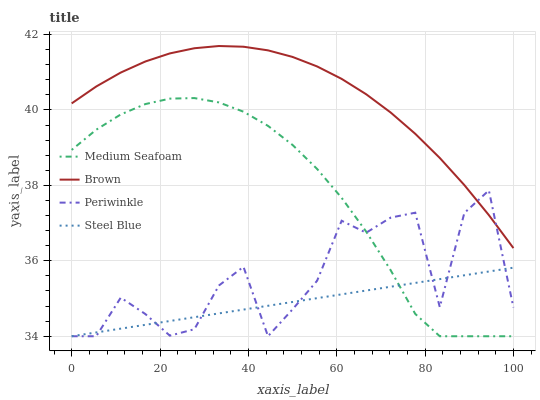Does Steel Blue have the minimum area under the curve?
Answer yes or no. Yes. Does Brown have the maximum area under the curve?
Answer yes or no. Yes. Does Periwinkle have the minimum area under the curve?
Answer yes or no. No. Does Periwinkle have the maximum area under the curve?
Answer yes or no. No. Is Steel Blue the smoothest?
Answer yes or no. Yes. Is Periwinkle the roughest?
Answer yes or no. Yes. Is Medium Seafoam the smoothest?
Answer yes or no. No. Is Medium Seafoam the roughest?
Answer yes or no. No. Does Periwinkle have the lowest value?
Answer yes or no. Yes. Does Brown have the highest value?
Answer yes or no. Yes. Does Periwinkle have the highest value?
Answer yes or no. No. Is Medium Seafoam less than Brown?
Answer yes or no. Yes. Is Brown greater than Steel Blue?
Answer yes or no. Yes. Does Brown intersect Periwinkle?
Answer yes or no. Yes. Is Brown less than Periwinkle?
Answer yes or no. No. Is Brown greater than Periwinkle?
Answer yes or no. No. Does Medium Seafoam intersect Brown?
Answer yes or no. No. 